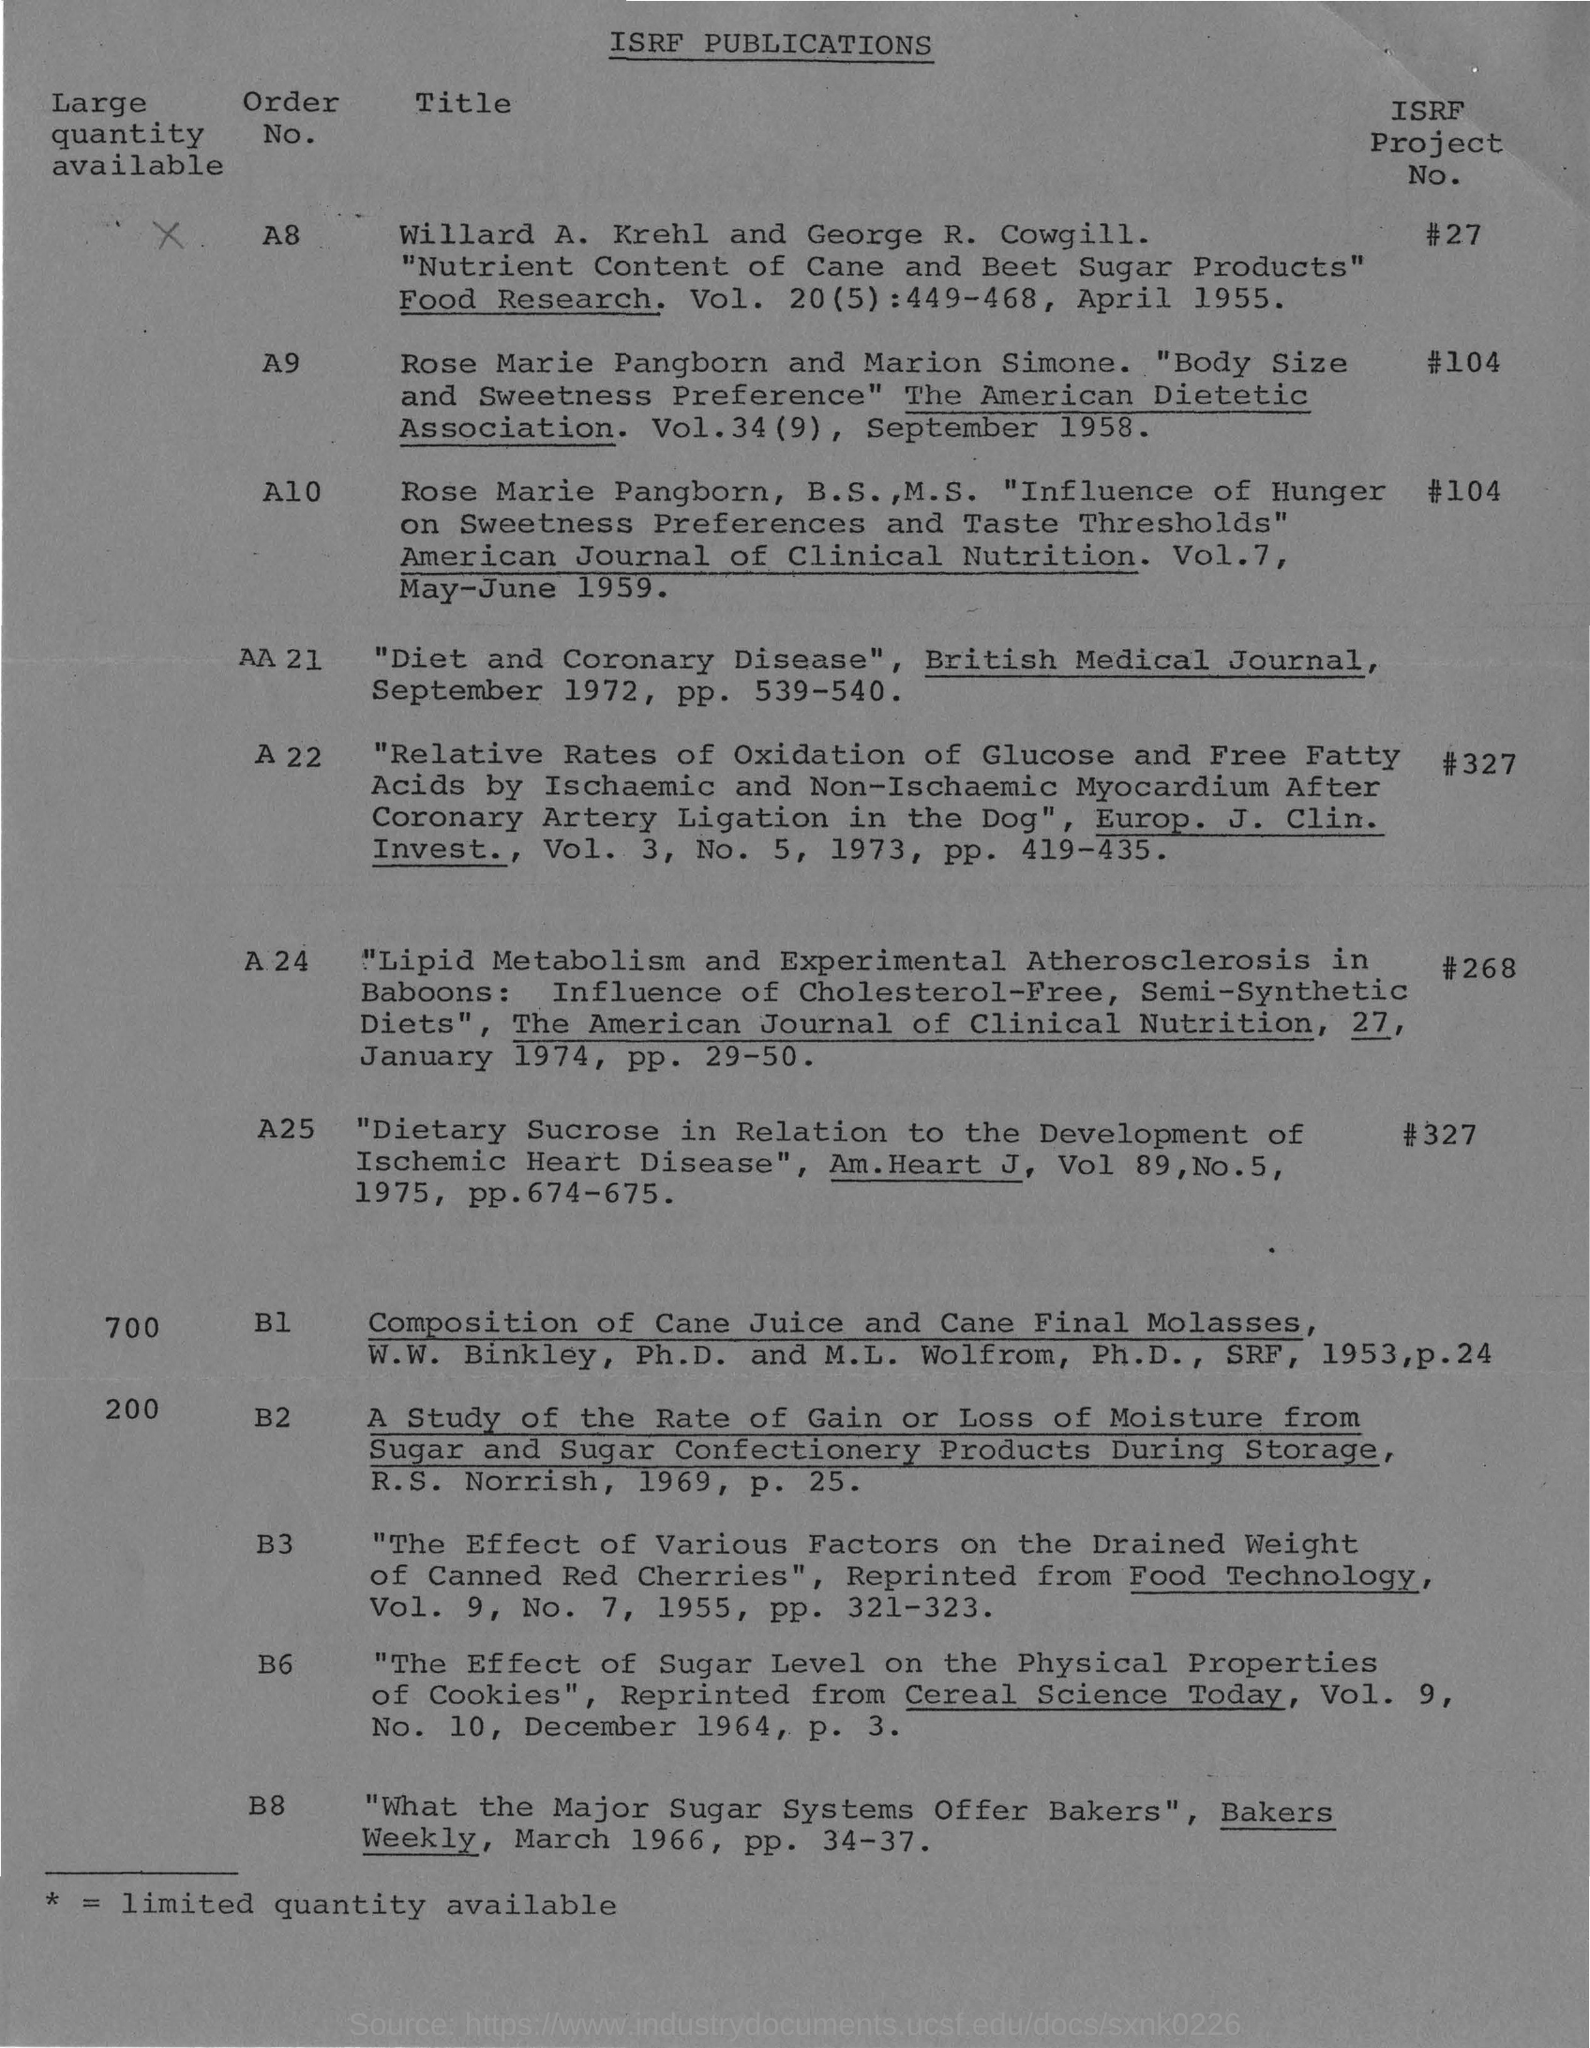Point out several critical features in this image. What is the number of the ISRF project known as 'ISRF project no. #27' with an A8 prefix? What is the order number of the ISRF project number 268? #268? 